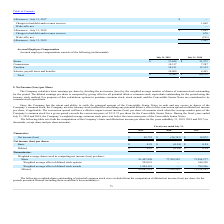According to Guidewire Software's financial document, How is the basic earnings per share calculated? by dividing the net income (loss) by the weighted average number of shares of common stock outstanding for the period.. The document states: "The Company calculates basic earnings per share by dividing the net income (loss) by the weighted average number of shares of common stock outstanding..." Also, What was the Net income (loss) in 2019, 2018 and 2017 respectively? The document contains multiple relevant values: $20,732, $(26,743), $18,072 (in thousands). From the document: "Net income (loss) $ 20,732 $ (26,743) $ 18,072 Net income (loss) $ 20,732 $ (26,743) $ 18,072 Net income (loss) $ 20,732 $ (26,743) $ 18,072..." Also, What was the basic Net income (loss) per share in 2019? According to the financial document, $0.25. The relevant text states: "Basic $ 0.25 $ (0.34) $ 0.24..." Additionally, In which year was basic Net income (loss) per share negative? According to the financial document, 2018. The relevant text states: "2019 2018 2017..." Also, can you calculate: What was the change in the basic Weighted average shares used in computing net income (loss) per share from 2018 to 2019? Based on the calculation: 81,447,998 - 77,709,592, the result is 3738406. This is based on the information: "Basic 81,447,998 77,709,592 73,994,577 Basic 81,447,998 77,709,592 73,994,577..." The key data points involved are: 77,709,592, 81,447,998. Also, can you calculate: What was the average Diluted Weighted average shares used in computing net income (loss) per share for 2018 and 2019? To answer this question, I need to perform calculations using the financial data. The calculation is: (82,681,214 + 77,709,592 + 75,328,343) / 3, which equals 78573049.67. This is based on the information: "Diluted 82,681,214 77,709,592 75,328,343 Diluted 82,681,214 77,709,592 75,328,343 Diluted 82,681,214 77,709,592 75,328,343..." The key data points involved are: 75,328,343, 77,709,592, 82,681,214. 